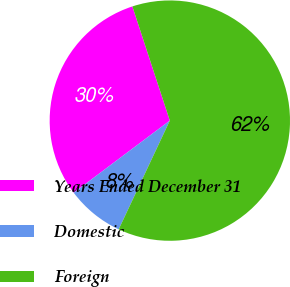Convert chart to OTSL. <chart><loc_0><loc_0><loc_500><loc_500><pie_chart><fcel>Years Ended December 31<fcel>Domestic<fcel>Foreign<nl><fcel>30.2%<fcel>7.76%<fcel>62.04%<nl></chart> 